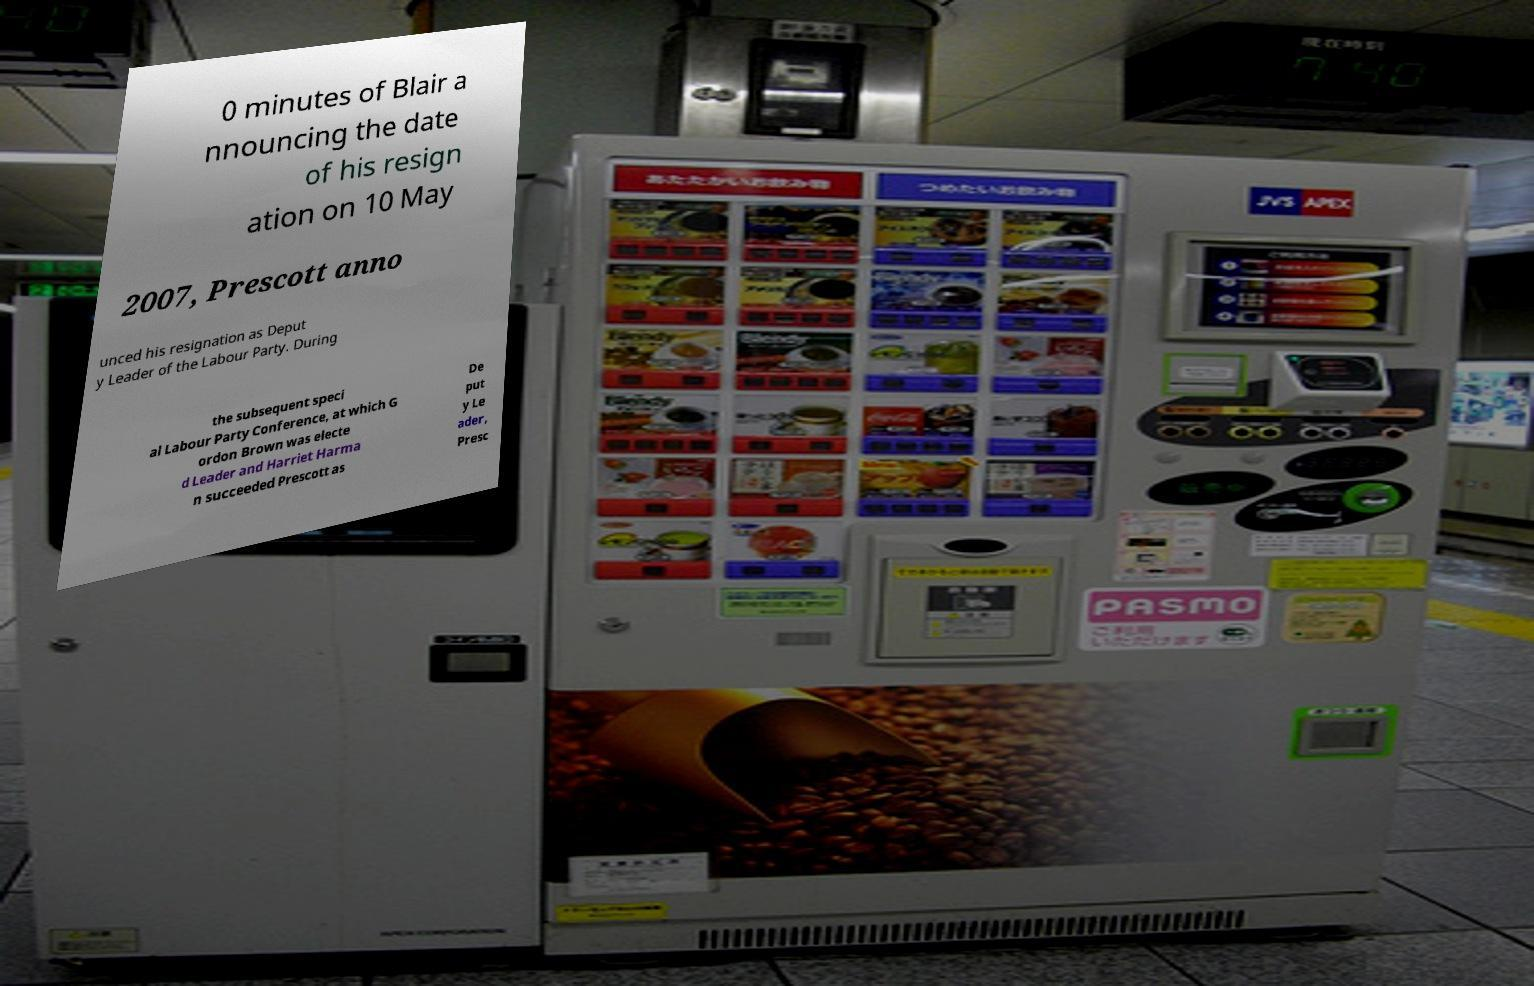I need the written content from this picture converted into text. Can you do that? 0 minutes of Blair a nnouncing the date of his resign ation on 10 May 2007, Prescott anno unced his resignation as Deput y Leader of the Labour Party. During the subsequent speci al Labour Party Conference, at which G ordon Brown was electe d Leader and Harriet Harma n succeeded Prescott as De put y Le ader, Presc 